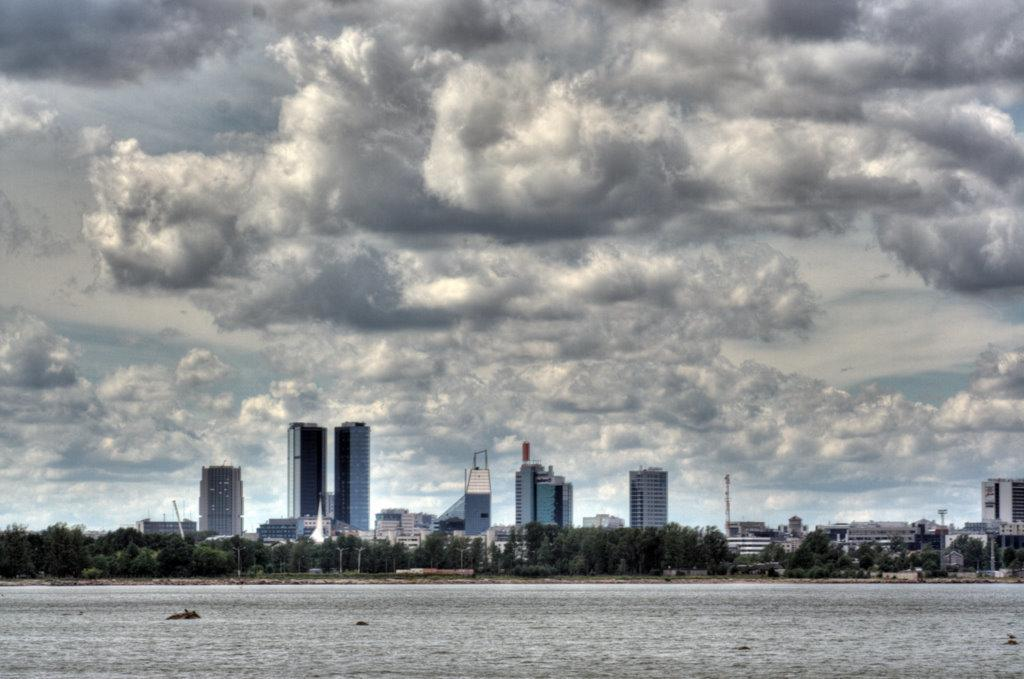What is at the bottom of the image? There is water at the bottom of the image. What can be seen in the background of the image? There are many trees and buildings in the background of the image. What is visible at the top of the image? The sky is visible at the top of the image. What can be observed in the sky? Clouds are present in the sky. Is there a plough visible in the image? No, there is no plough present in the image. What type of rainstorm can be seen in the image? There is no rainstorm present in the image; it only shows water, trees, buildings, sky, and clouds. 